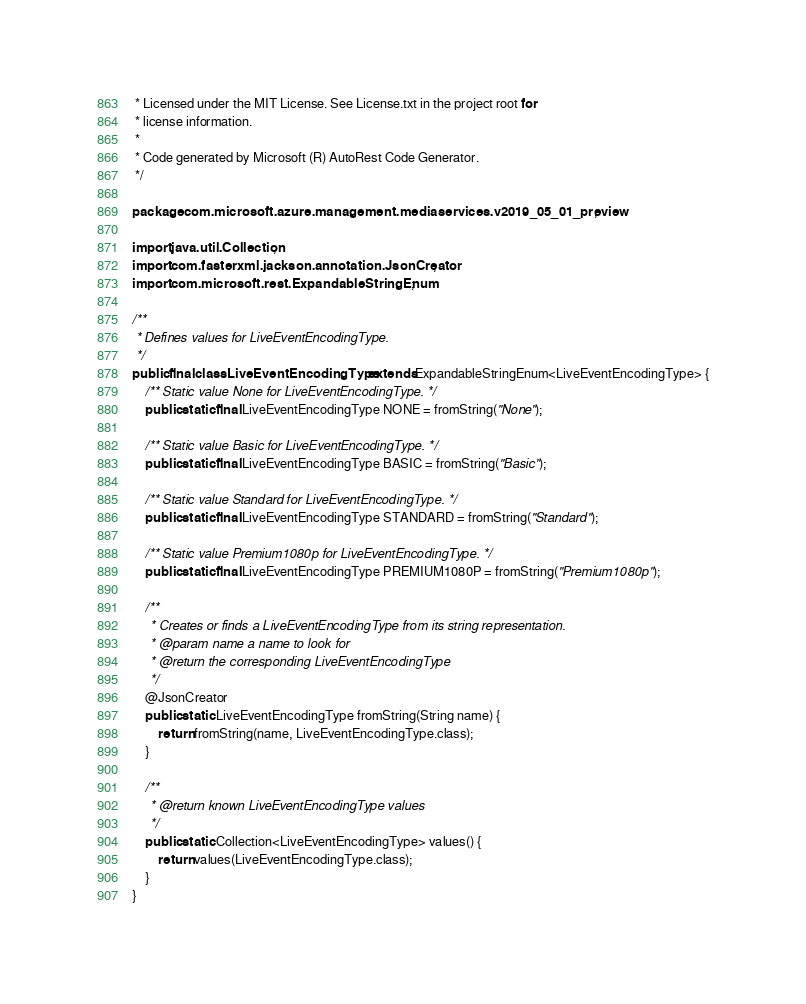Convert code to text. <code><loc_0><loc_0><loc_500><loc_500><_Java_> * Licensed under the MIT License. See License.txt in the project root for
 * license information.
 *
 * Code generated by Microsoft (R) AutoRest Code Generator.
 */

package com.microsoft.azure.management.mediaservices.v2019_05_01_preview;

import java.util.Collection;
import com.fasterxml.jackson.annotation.JsonCreator;
import com.microsoft.rest.ExpandableStringEnum;

/**
 * Defines values for LiveEventEncodingType.
 */
public final class LiveEventEncodingType extends ExpandableStringEnum<LiveEventEncodingType> {
    /** Static value None for LiveEventEncodingType. */
    public static final LiveEventEncodingType NONE = fromString("None");

    /** Static value Basic for LiveEventEncodingType. */
    public static final LiveEventEncodingType BASIC = fromString("Basic");

    /** Static value Standard for LiveEventEncodingType. */
    public static final LiveEventEncodingType STANDARD = fromString("Standard");

    /** Static value Premium1080p for LiveEventEncodingType. */
    public static final LiveEventEncodingType PREMIUM1080P = fromString("Premium1080p");

    /**
     * Creates or finds a LiveEventEncodingType from its string representation.
     * @param name a name to look for
     * @return the corresponding LiveEventEncodingType
     */
    @JsonCreator
    public static LiveEventEncodingType fromString(String name) {
        return fromString(name, LiveEventEncodingType.class);
    }

    /**
     * @return known LiveEventEncodingType values
     */
    public static Collection<LiveEventEncodingType> values() {
        return values(LiveEventEncodingType.class);
    }
}
</code> 